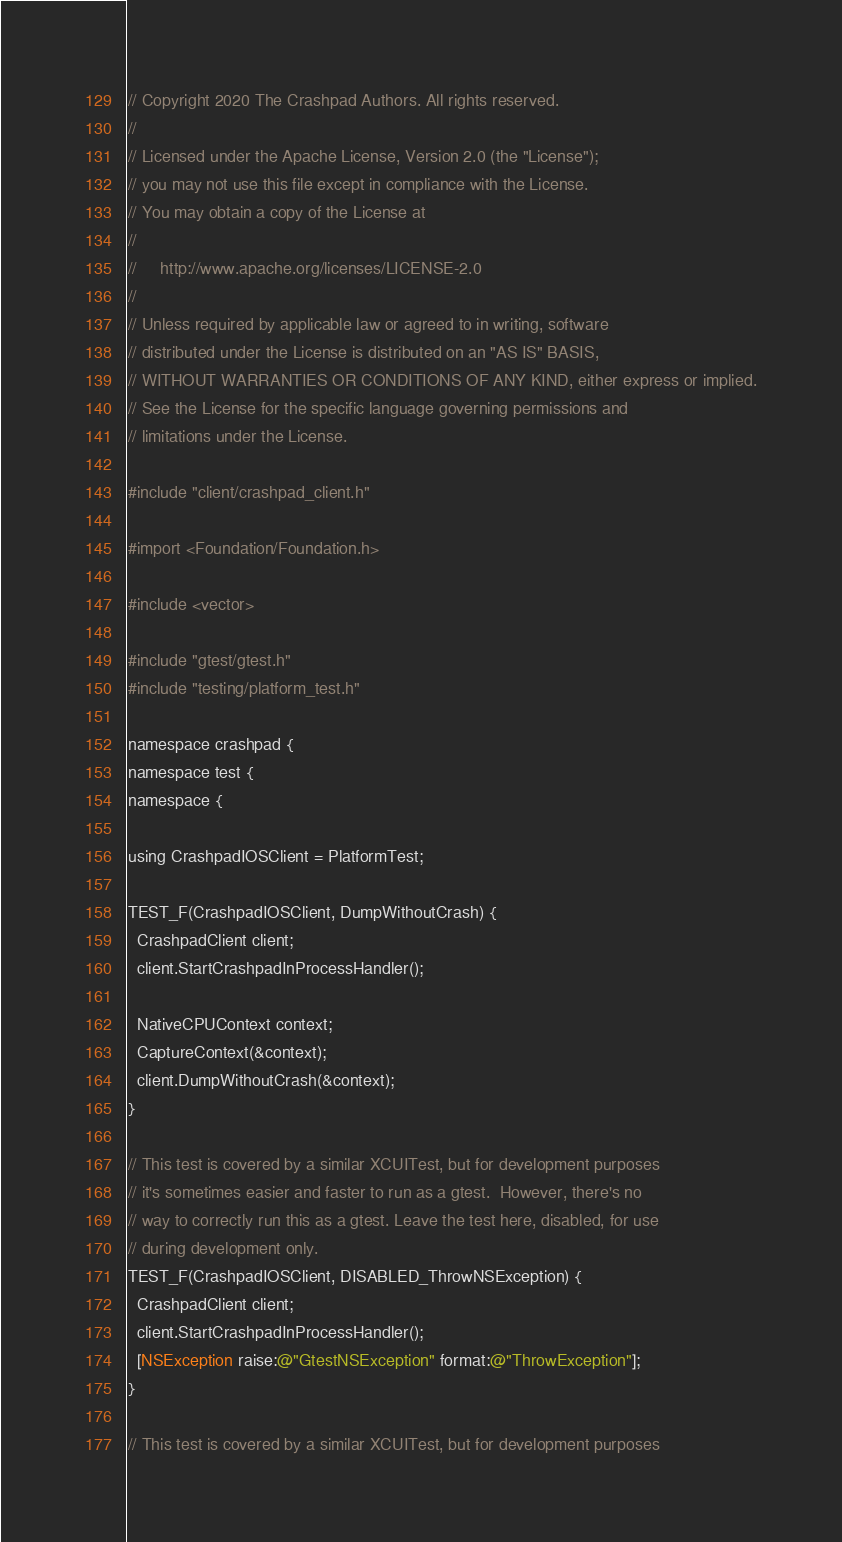<code> <loc_0><loc_0><loc_500><loc_500><_ObjectiveC_>// Copyright 2020 The Crashpad Authors. All rights reserved.
//
// Licensed under the Apache License, Version 2.0 (the "License");
// you may not use this file except in compliance with the License.
// You may obtain a copy of the License at
//
//     http://www.apache.org/licenses/LICENSE-2.0
//
// Unless required by applicable law or agreed to in writing, software
// distributed under the License is distributed on an "AS IS" BASIS,
// WITHOUT WARRANTIES OR CONDITIONS OF ANY KIND, either express or implied.
// See the License for the specific language governing permissions and
// limitations under the License.

#include "client/crashpad_client.h"

#import <Foundation/Foundation.h>

#include <vector>

#include "gtest/gtest.h"
#include "testing/platform_test.h"

namespace crashpad {
namespace test {
namespace {

using CrashpadIOSClient = PlatformTest;

TEST_F(CrashpadIOSClient, DumpWithoutCrash) {
  CrashpadClient client;
  client.StartCrashpadInProcessHandler();

  NativeCPUContext context;
  CaptureContext(&context);
  client.DumpWithoutCrash(&context);
}

// This test is covered by a similar XCUITest, but for development purposes
// it's sometimes easier and faster to run as a gtest.  However, there's no
// way to correctly run this as a gtest. Leave the test here, disabled, for use
// during development only.
TEST_F(CrashpadIOSClient, DISABLED_ThrowNSException) {
  CrashpadClient client;
  client.StartCrashpadInProcessHandler();
  [NSException raise:@"GtestNSException" format:@"ThrowException"];
}

// This test is covered by a similar XCUITest, but for development purposes</code> 